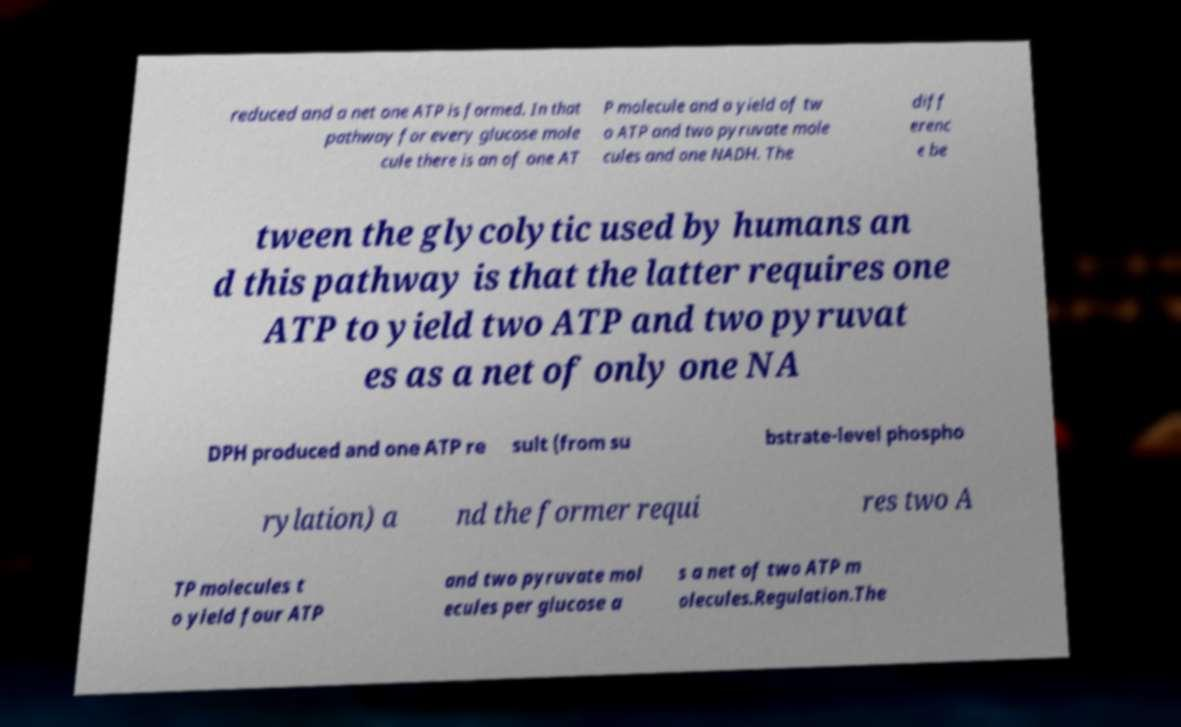Please identify and transcribe the text found in this image. reduced and a net one ATP is formed. In that pathway for every glucose mole cule there is an of one AT P molecule and a yield of tw o ATP and two pyruvate mole cules and one NADH. The diff erenc e be tween the glycolytic used by humans an d this pathway is that the latter requires one ATP to yield two ATP and two pyruvat es as a net of only one NA DPH produced and one ATP re sult (from su bstrate-level phospho rylation) a nd the former requi res two A TP molecules t o yield four ATP and two pyruvate mol ecules per glucose a s a net of two ATP m olecules.Regulation.The 